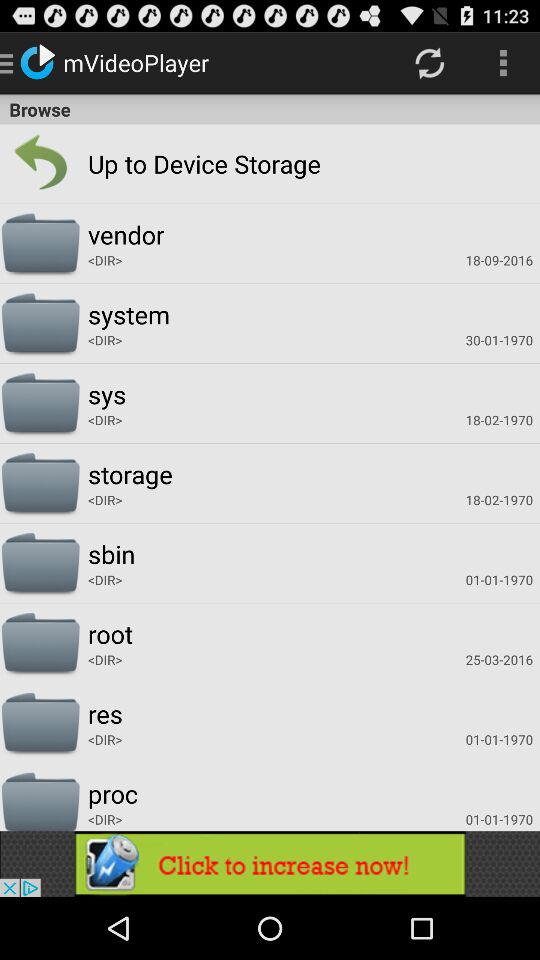What is the name of application? The name of application is "mVideoPlayer". 